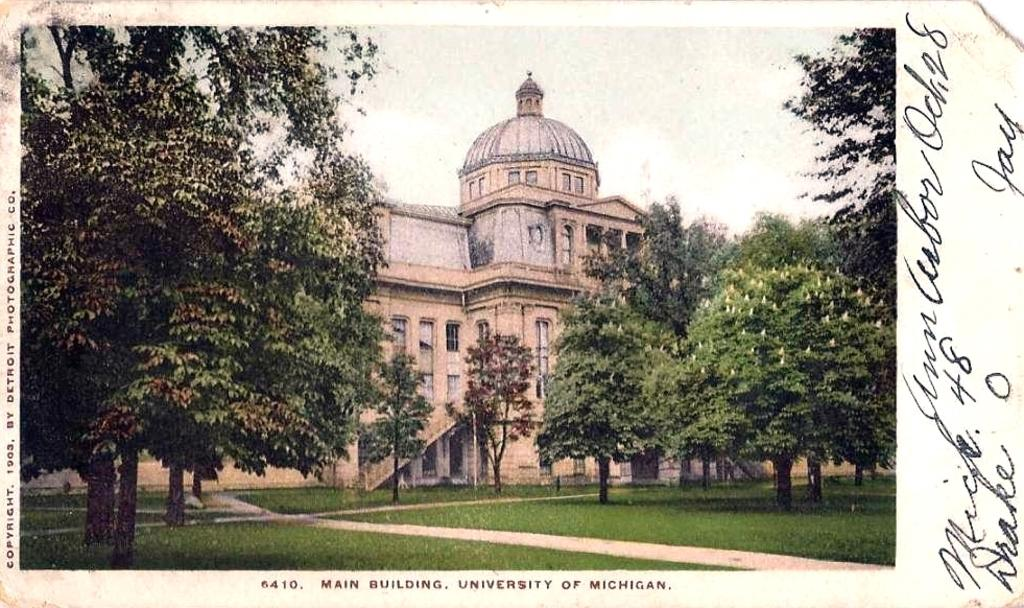What type of structure is present in the image? There is a building in the image. What feature can be seen on the building? The building has windows. What type of vegetation is present in the image? There are trees in the image. What part of the natural environment is visible in the image? The sky is visible in the image. What type of surface can be seen in the image? There is a path in the image. What type of ground cover is present in the image? There is grass in the image. What type of text is present in the image? There is printed text in the image. What type of attraction does the grandfather take the children to in the image? There is no grandfather or children present in the image, and therefore no such activity can be observed. 